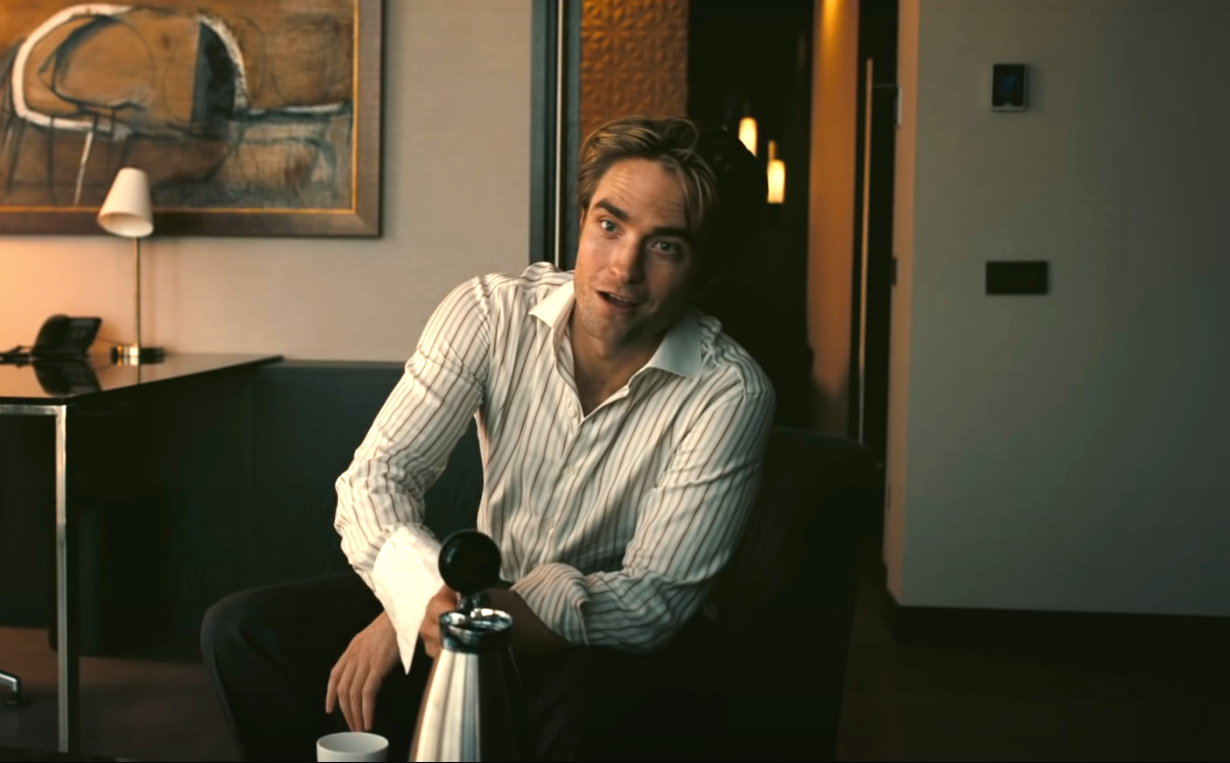Can you describe the atmosphere and mood in the image? The atmosphere in the image is one of sophistication and calm. The man seated on the black leather couch appears relaxed and content, indicated by his comfortable posture and slight smile. The setting, a tastefully decorated living room with modern decor including a painting and a lamp, radiates an air of elegance and tranquility. The soft lighting and muted colors further enhance the peaceful and refined ambiance, making it a serene and inviting space. 